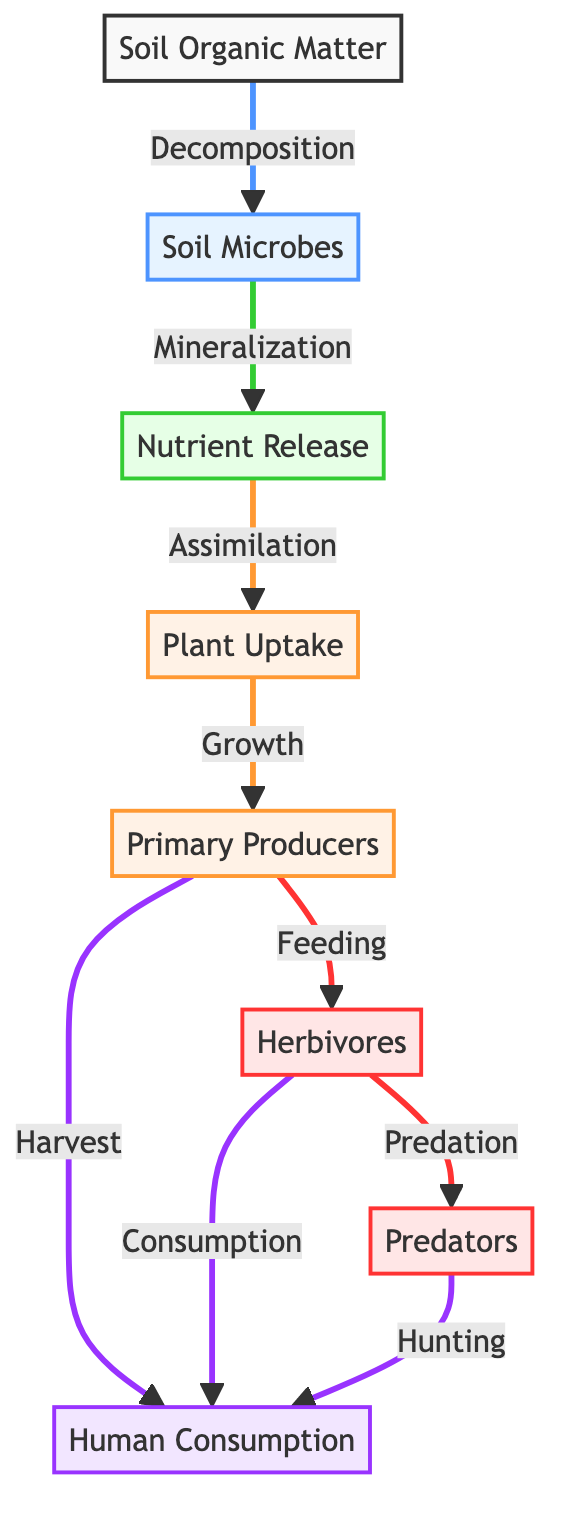What is the starting point of the food chain? The diagram indicates that the starting point is "Soil Organic Matter," which is the initial node that initiates the flow to soil microbes.
Answer: Soil Organic Matter How many nodes are in the diagram? By counting each labeled component represented in the diagram, we find there are eight distinct nodes.
Answer: 8 What process leads to nutrient release? The diagram shows that "Decomposition" by soil microbes leads to nutrient release as part of the flow.
Answer: Decomposition Which group directly consumes plants? According to the diagram, "Herbivores" are the group that directly feeds on plants, indicated by the flow from "Primary Producers" to "Herbivores."
Answer: Herbivores What is the relationship between soil microbes and nutrient release? The diagram illustrates that soil microbes perform "Mineralization," which is the process that releases nutrients. This indicates a direct relationship between microbes and nutrient availability.
Answer: Mineralization What process connects primary producers and herbivores? The connection between "Primary Producers" and "Herbivores" is through the "Feeding" process, as shown in the flow of the diagram.
Answer: Feeding How do humans obtain nutrients through the food chain? The diagram shows that humans obtain nutrients through two pathways: by harvesting from plants and by consuming herbivores, indicated by flows from both "Primary Producers" and "Herbivores" to "Human Consumption."
Answer: Harvest and Consumption What type of organisms are directly between soil organic matter and nutrient release? The organisms directly between "Soil Organic Matter" and "Nutrient Release" are "Soil Microbes," highlighted in the flow of the diagram.
Answer: Soil Microbes In what sequence do herbivores and predators interact with humans? The diagram indicates that both herbivores and predators lead to "Human Consumption" but follow different processes. Herbivores are consumed directly, while predators are also hunted, demonstrating varied interactions before reaching humans.
Answer: Different processes (Herbivores consume, Predators hunt) 